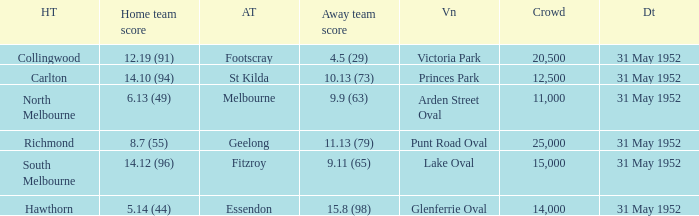Who was the away team at the game at Victoria Park? Footscray. 